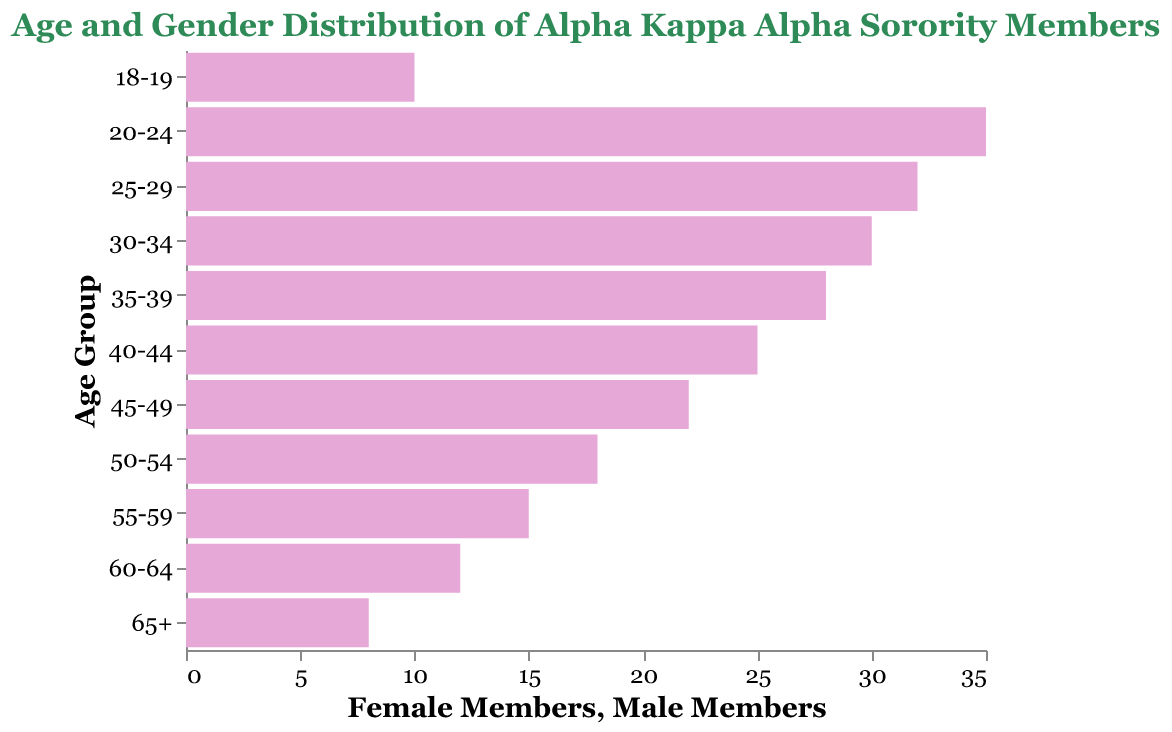What is the title of the figure? The title is typically placed at the top of the figure and represents the subject being depicted. Here, the title clarifies that the figure illustrates the age and gender distribution of Alpha Kappa Alpha sorority members.
Answer: Age and Gender Distribution of Alpha Kappa Alpha Sorority Members What age group has the highest number of female members? To determine this, look at the bars representing female members and identify the longest bar.
Answer: 20-24 How many age groups are represented in the figure? Count the unique age groups listed on the y-axis.
Answer: 11 What age group has the lowest number of female members? Identify the age group with the shortest bar among female members.
Answer: 65+ By how many members does the age group 30-34 exceed the age group 40-44 in female members? Subtract the number of female members in the 40-44 age group from the 30-34 age group. 30-34 has 30 members, and 40-44 has 25 members. The difference is 30 - 25 = 5.
Answer: 5 What is the total number of female members aged 55 and above? Add the number of female members from the age groups 55-59, 60-64, and 65+. It is 15 + 12 + 8 = 35.
Answer: 35 Compare the sum of female members in the age groups 20-24 and 25-29 to the sum in the age groups 30-34 and 35-39. Which sum is larger and by how much? First, find the sum for each set of age groups. For 20-24 and 25-29: 35 + 32 = 67. For 30-34 and 35-39: 30 + 28 = 58. The difference is 67 - 58 = 9.
Answer: 20-24 and 25-29, by 9 Which age group shows exactly 22 female members? Look at the bars for female members and find the one labeled 22.
Answer: 45-49 Are there any male members represented in the figure? Since the Male bar length is zero for all age groups, there are no male members.
Answer: No What pattern can be observed in the distribution of female members across different age groups? By analyzing the lengths of the bars representing female members, it becomes apparent that the number grows steadily from the 18-19 age group, peaks in the 20-24 age group, and then gradually declines for older age groups.
Answer: Peaks at 20-24 